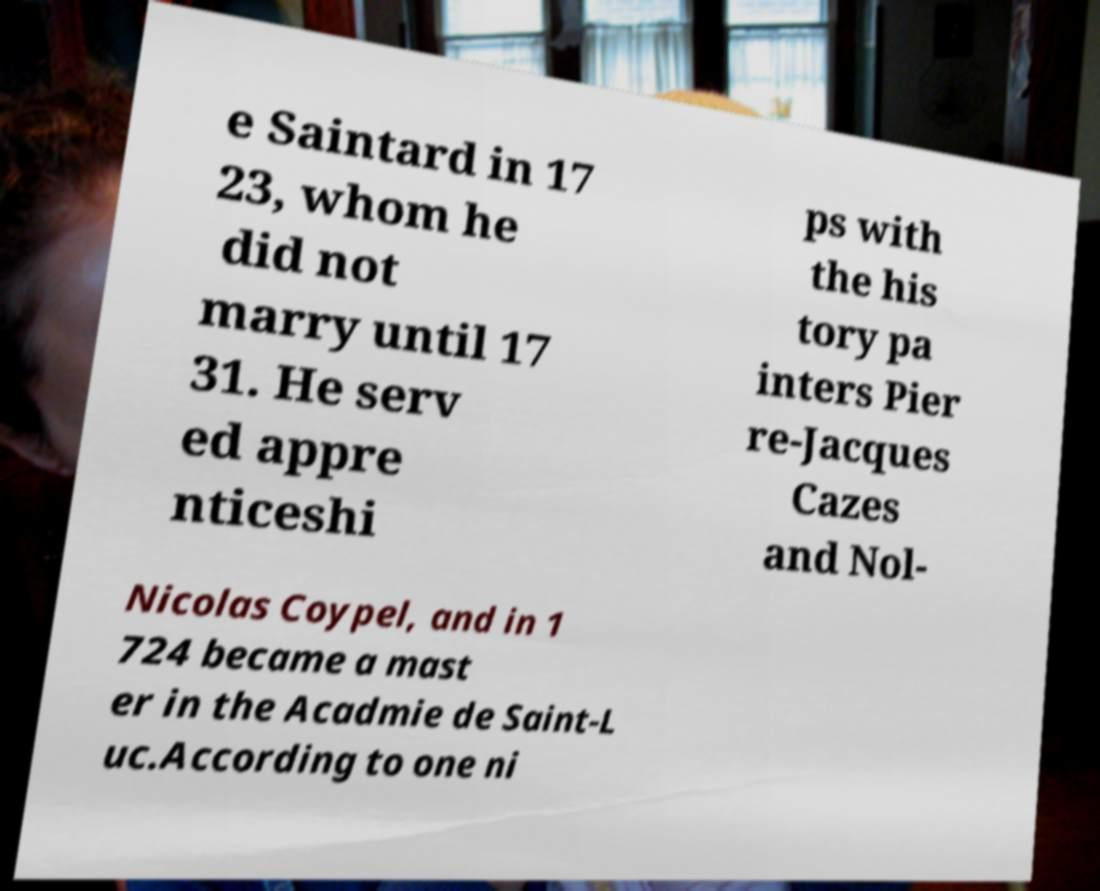There's text embedded in this image that I need extracted. Can you transcribe it verbatim? e Saintard in 17 23, whom he did not marry until 17 31. He serv ed appre nticeshi ps with the his tory pa inters Pier re-Jacques Cazes and Nol- Nicolas Coypel, and in 1 724 became a mast er in the Acadmie de Saint-L uc.According to one ni 